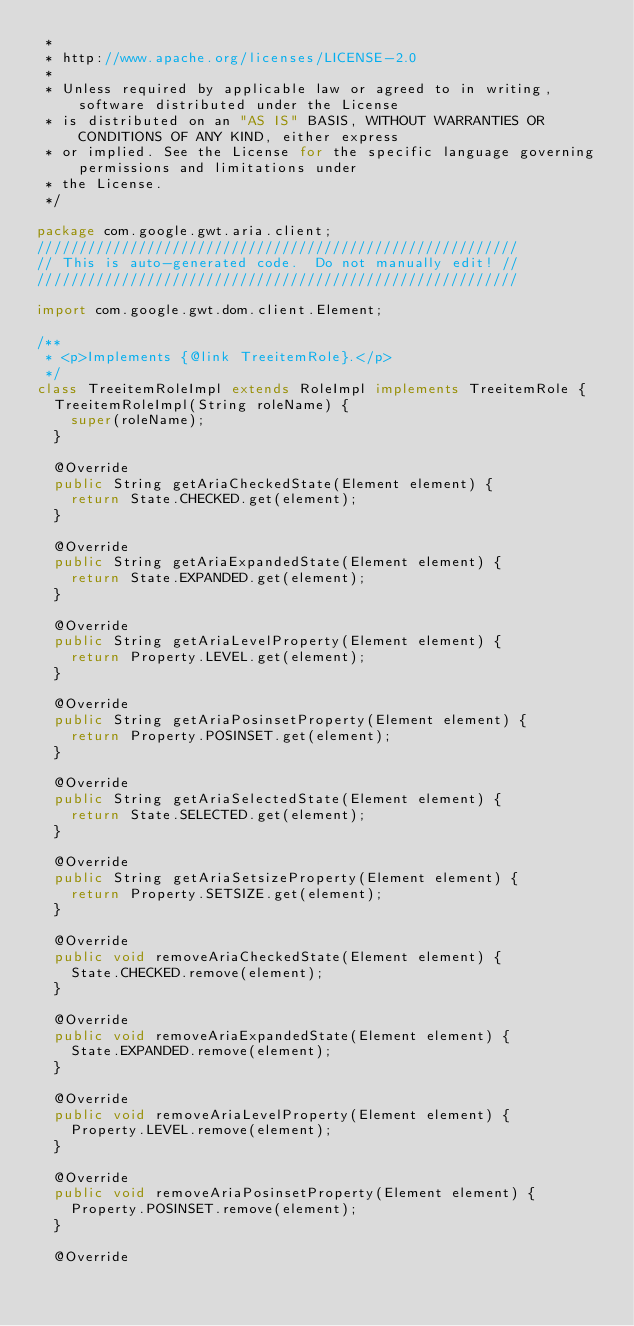Convert code to text. <code><loc_0><loc_0><loc_500><loc_500><_Java_> *
 * http://www.apache.org/licenses/LICENSE-2.0
 *
 * Unless required by applicable law or agreed to in writing, software distributed under the License
 * is distributed on an "AS IS" BASIS, WITHOUT WARRANTIES OR CONDITIONS OF ANY KIND, either express
 * or implied. See the License for the specific language governing permissions and limitations under
 * the License.
 */

package com.google.gwt.aria.client;
/////////////////////////////////////////////////////////
// This is auto-generated code.  Do not manually edit! //
/////////////////////////////////////////////////////////

import com.google.gwt.dom.client.Element;

/**
 * <p>Implements {@link TreeitemRole}.</p>
 */
class TreeitemRoleImpl extends RoleImpl implements TreeitemRole {
  TreeitemRoleImpl(String roleName) {
    super(roleName);
  }

  @Override
  public String getAriaCheckedState(Element element) {
    return State.CHECKED.get(element);
  }

  @Override
  public String getAriaExpandedState(Element element) {
    return State.EXPANDED.get(element);
  }

  @Override
  public String getAriaLevelProperty(Element element) {
    return Property.LEVEL.get(element);
  }

  @Override
  public String getAriaPosinsetProperty(Element element) {
    return Property.POSINSET.get(element);
  }

  @Override
  public String getAriaSelectedState(Element element) {
    return State.SELECTED.get(element);
  }

  @Override
  public String getAriaSetsizeProperty(Element element) {
    return Property.SETSIZE.get(element);
  }

  @Override
  public void removeAriaCheckedState(Element element) {
    State.CHECKED.remove(element);
  }

  @Override
  public void removeAriaExpandedState(Element element) {
    State.EXPANDED.remove(element);
  }

  @Override
  public void removeAriaLevelProperty(Element element) {
    Property.LEVEL.remove(element);
  }

  @Override
  public void removeAriaPosinsetProperty(Element element) {
    Property.POSINSET.remove(element);
  }

  @Override</code> 